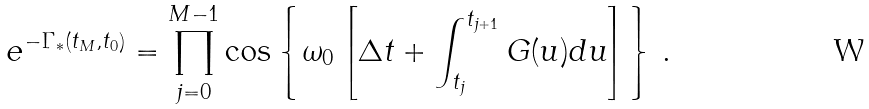Convert formula to latex. <formula><loc_0><loc_0><loc_500><loc_500>e ^ { - \Gamma _ { * } ( t _ { M } , t _ { 0 } ) } = \prod _ { j = 0 } ^ { M - 1 } \cos \left \{ \omega _ { 0 } \left [ \Delta t + \int _ { t _ { j } } ^ { t _ { j + 1 } } G ( u ) d u \right ] \right \} \, .</formula> 